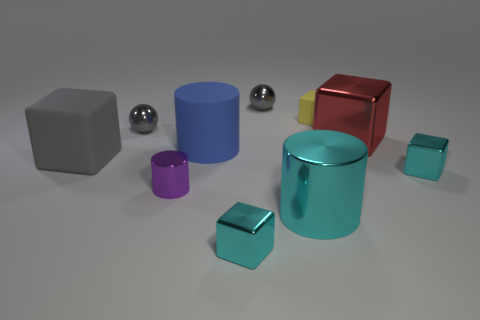Is there a gray ball that has the same material as the small purple cylinder?
Ensure brevity in your answer.  Yes. How many small green metallic cylinders are there?
Make the answer very short. 0. What material is the tiny gray ball that is on the right side of the large rubber cylinder right of the tiny purple metallic cylinder made of?
Provide a short and direct response. Metal. There is a cylinder that is made of the same material as the tiny yellow object; what color is it?
Make the answer very short. Blue. Is the size of the shiny cube that is right of the red metallic block the same as the matte cube right of the gray block?
Provide a short and direct response. Yes. How many balls are big blue objects or gray matte objects?
Provide a succinct answer. 0. Does the big cylinder that is in front of the small purple metallic object have the same material as the small purple thing?
Give a very brief answer. Yes. What number of other objects are the same size as the purple cylinder?
Your answer should be compact. 5. What number of small objects are blue matte objects or red things?
Your answer should be compact. 0. Do the rubber cylinder and the tiny rubber cube have the same color?
Provide a short and direct response. No. 